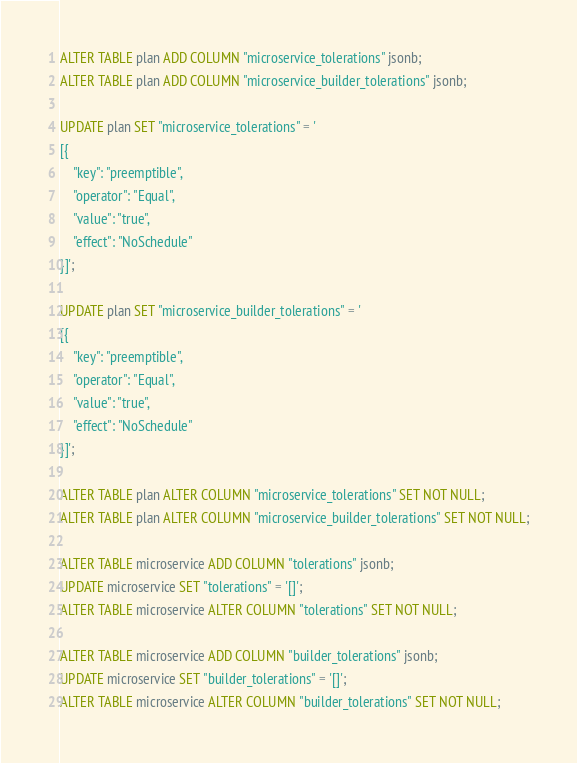<code> <loc_0><loc_0><loc_500><loc_500><_SQL_>ALTER TABLE plan ADD COLUMN "microservice_tolerations" jsonb;
ALTER TABLE plan ADD COLUMN "microservice_builder_tolerations" jsonb;

UPDATE plan SET "microservice_tolerations" = '
[{
    "key": "preemptible",
    "operator": "Equal",
    "value": "true",
    "effect": "NoSchedule"
}]';

UPDATE plan SET "microservice_builder_tolerations" = '
[{
    "key": "preemptible",
    "operator": "Equal",
    "value": "true",
    "effect": "NoSchedule"
}]';

ALTER TABLE plan ALTER COLUMN "microservice_tolerations" SET NOT NULL;
ALTER TABLE plan ALTER COLUMN "microservice_builder_tolerations" SET NOT NULL;

ALTER TABLE microservice ADD COLUMN "tolerations" jsonb;
UPDATE microservice SET "tolerations" = '[]';
ALTER TABLE microservice ALTER COLUMN "tolerations" SET NOT NULL;

ALTER TABLE microservice ADD COLUMN "builder_tolerations" jsonb;
UPDATE microservice SET "builder_tolerations" = '[]';
ALTER TABLE microservice ALTER COLUMN "builder_tolerations" SET NOT NULL;
</code> 